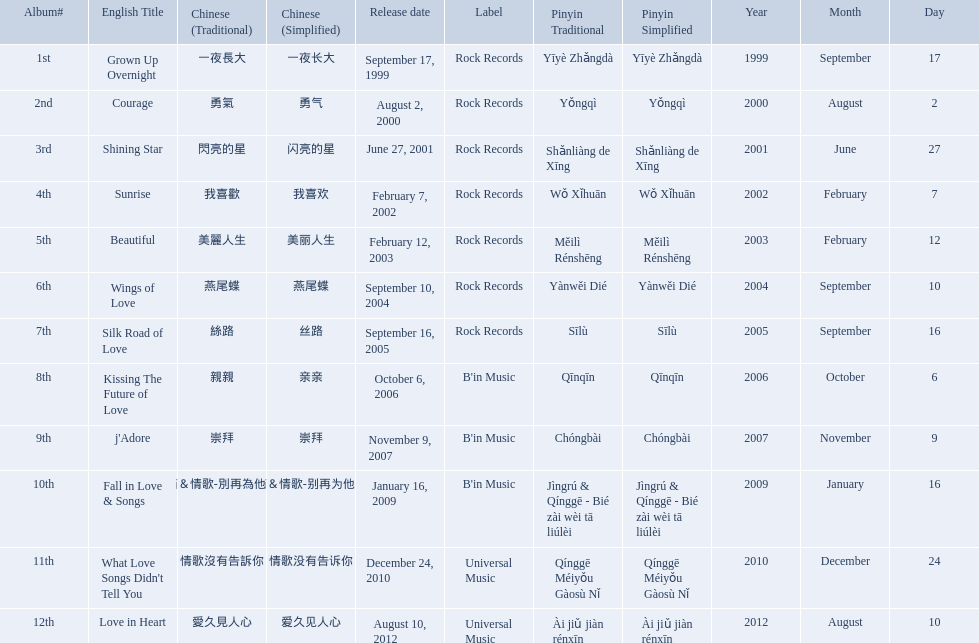Which english titles were released during even years? Courage, Sunrise, Silk Road of Love, Kissing The Future of Love, What Love Songs Didn't Tell You, Love in Heart. Out of the following, which one was released under b's in music? Kissing The Future of Love. Which songs did b'in music produce? Kissing The Future of Love, j'Adore, Fall in Love & Songs. Which one was released in an even numbered year? Kissing The Future of Love. Write the full table. {'header': ['Album#', 'English Title', 'Chinese (Traditional)', 'Chinese (Simplified)', 'Release date', 'Label', 'Pinyin Traditional', 'Pinyin Simplified', 'Year', 'Month', 'Day'], 'rows': [['1st', 'Grown Up Overnight', '一夜長大', '一夜长大', 'September 17, 1999', 'Rock Records', 'Yīyè Zhǎngdà', 'Yīyè Zhǎngdà', '1999', 'September', '17'], ['2nd', 'Courage', '勇氣', '勇气', 'August 2, 2000', 'Rock Records', 'Yǒngqì', 'Yǒngqì', '2000', 'August', '2'], ['3rd', 'Shining Star', '閃亮的星', '闪亮的星', 'June 27, 2001', 'Rock Records', 'Shǎnliàng de Xīng', 'Shǎnliàng de Xīng', '2001', 'June', '27'], ['4th', 'Sunrise', '我喜歡', '我喜欢', 'February 7, 2002', 'Rock Records', 'Wǒ Xǐhuān', 'Wǒ Xǐhuān', '2002', 'February', '7'], ['5th', 'Beautiful', '美麗人生', '美丽人生', 'February 12, 2003', 'Rock Records', 'Měilì Rénshēng', 'Měilì Rénshēng', '2003', 'February', '12'], ['6th', 'Wings of Love', '燕尾蝶', '燕尾蝶', 'September 10, 2004', 'Rock Records', 'Yànwěi Dié', 'Yànwěi Dié', '2004', 'September', '10'], ['7th', 'Silk Road of Love', '絲路', '丝路', 'September 16, 2005', 'Rock Records', 'Sīlù', 'Sīlù', '2005', 'September', '16'], ['8th', 'Kissing The Future of Love', '親親', '亲亲', 'October 6, 2006', "B'in Music", 'Qīnqīn', 'Qīnqīn', '2006', 'October', '6'], ['9th', "j'Adore", '崇拜', '崇拜', 'November 9, 2007', "B'in Music", 'Chóngbài', 'Chóngbài', '2007', 'November', '9'], ['10th', 'Fall in Love & Songs', '靜茹＆情歌-別再為他流淚', '静茹＆情歌-别再为他流泪', 'January 16, 2009', "B'in Music", 'Jìngrú & Qínggē - Bié zài wèi tā liúlèi', 'Jìngrú & Qínggē - Bié zài wèi tā liúlèi', '2009', 'January', '16'], ['11th', "What Love Songs Didn't Tell You", '情歌沒有告訴你', '情歌没有告诉你', 'December 24, 2010', 'Universal Music', 'Qínggē Méiyǒu Gàosù Nǐ', 'Qínggē Méiyǒu Gàosù Nǐ', '2010', 'December', '24'], ['12th', 'Love in Heart', '愛久見人心', '爱久见人心', 'August 10, 2012', 'Universal Music', 'Ài jiǔ jiàn rénxīn', 'Ài jiǔ jiàn rénxīn', '2012', 'August', '10']]} What were the albums? Grown Up Overnight, Courage, Shining Star, Sunrise, Beautiful, Wings of Love, Silk Road of Love, Kissing The Future of Love, j'Adore, Fall in Love & Songs, What Love Songs Didn't Tell You, Love in Heart. Which ones were released by b'in music? Kissing The Future of Love, j'Adore. Of these, which one was in an even-numbered year? Kissing The Future of Love. 